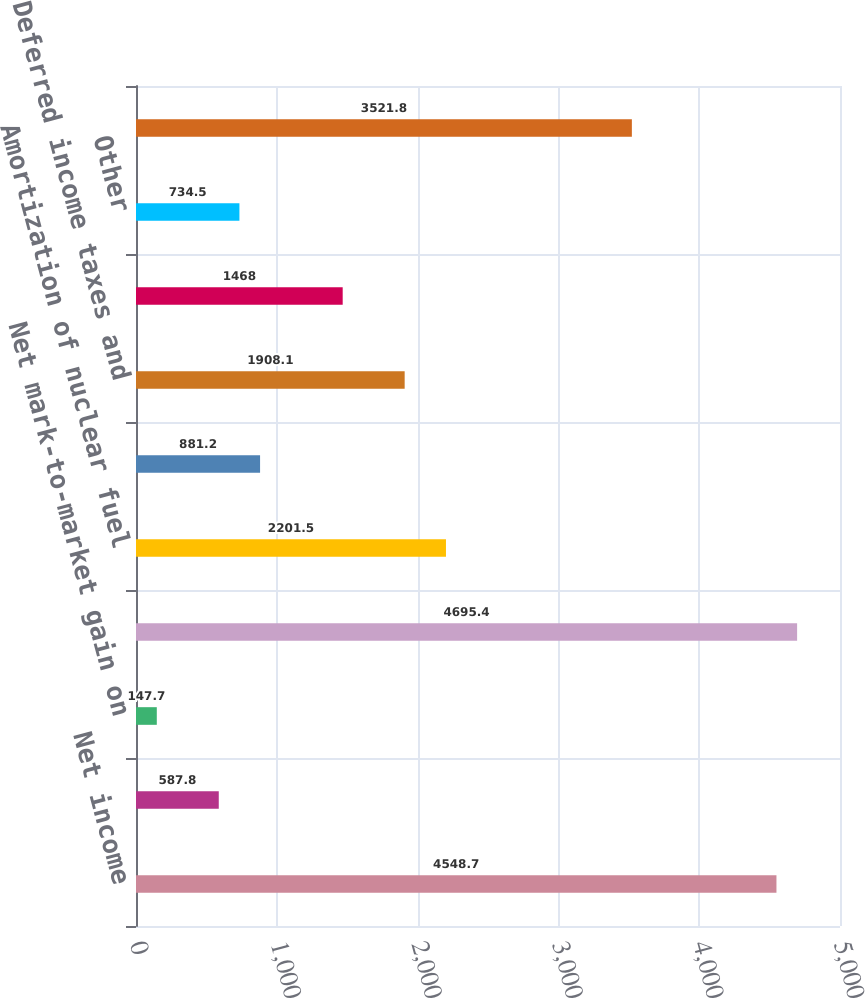Convert chart. <chart><loc_0><loc_0><loc_500><loc_500><bar_chart><fcel>Net income<fcel>Gain on sales of emission<fcel>Net mark-to-market gain on<fcel>Depreciation and amortization<fcel>Amortization of nuclear fuel<fcel>Amortization of debt issuance<fcel>Deferred income taxes and<fcel>Minority interest<fcel>Other<fcel>Receivables<nl><fcel>4548.7<fcel>587.8<fcel>147.7<fcel>4695.4<fcel>2201.5<fcel>881.2<fcel>1908.1<fcel>1468<fcel>734.5<fcel>3521.8<nl></chart> 